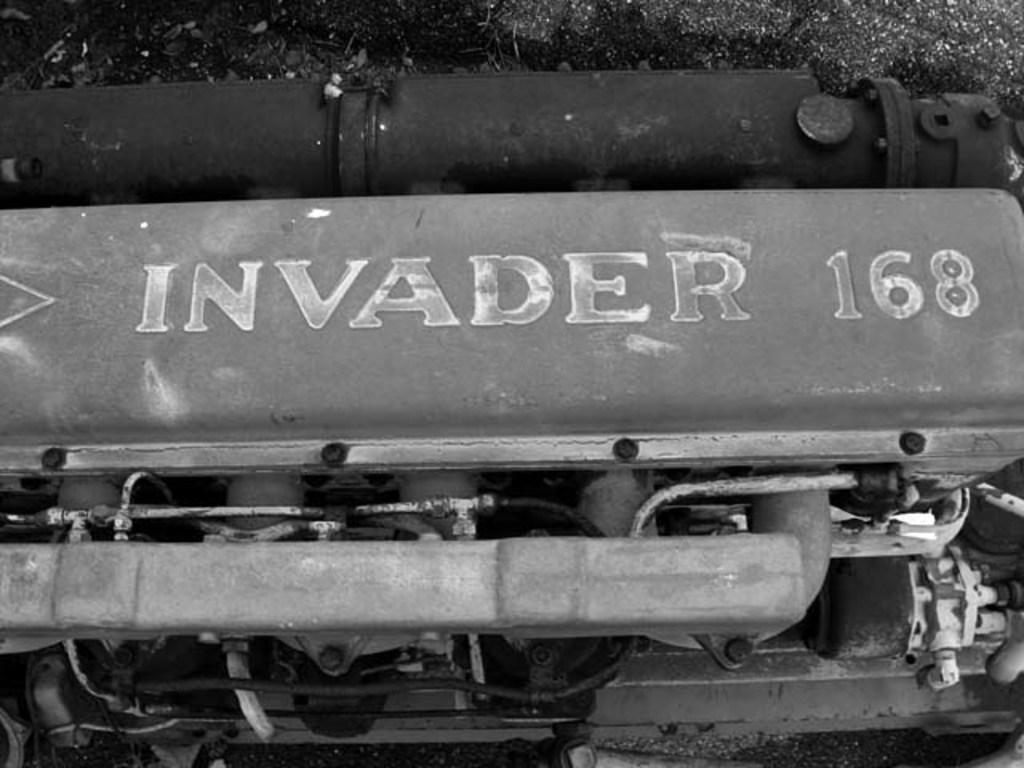What is written before 168?
Ensure brevity in your answer.  Invader. What number is written on this item?
Offer a very short reply. 168. 